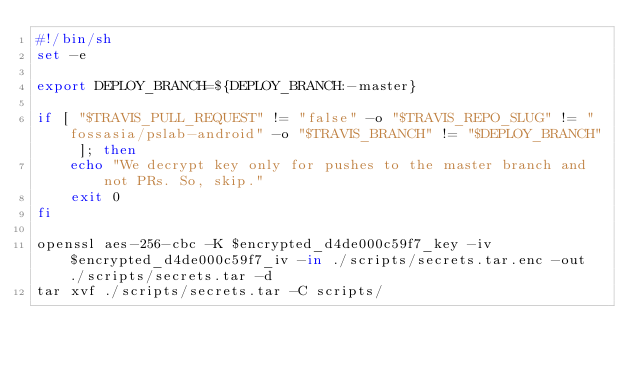Convert code to text. <code><loc_0><loc_0><loc_500><loc_500><_Bash_>#!/bin/sh
set -e

export DEPLOY_BRANCH=${DEPLOY_BRANCH:-master}

if [ "$TRAVIS_PULL_REQUEST" != "false" -o "$TRAVIS_REPO_SLUG" != "fossasia/pslab-android" -o "$TRAVIS_BRANCH" != "$DEPLOY_BRANCH" ]; then
    echo "We decrypt key only for pushes to the master branch and not PRs. So, skip."
    exit 0
fi

openssl aes-256-cbc -K $encrypted_d4de000c59f7_key -iv $encrypted_d4de000c59f7_iv -in ./scripts/secrets.tar.enc -out ./scripts/secrets.tar -d
tar xvf ./scripts/secrets.tar -C scripts/
</code> 